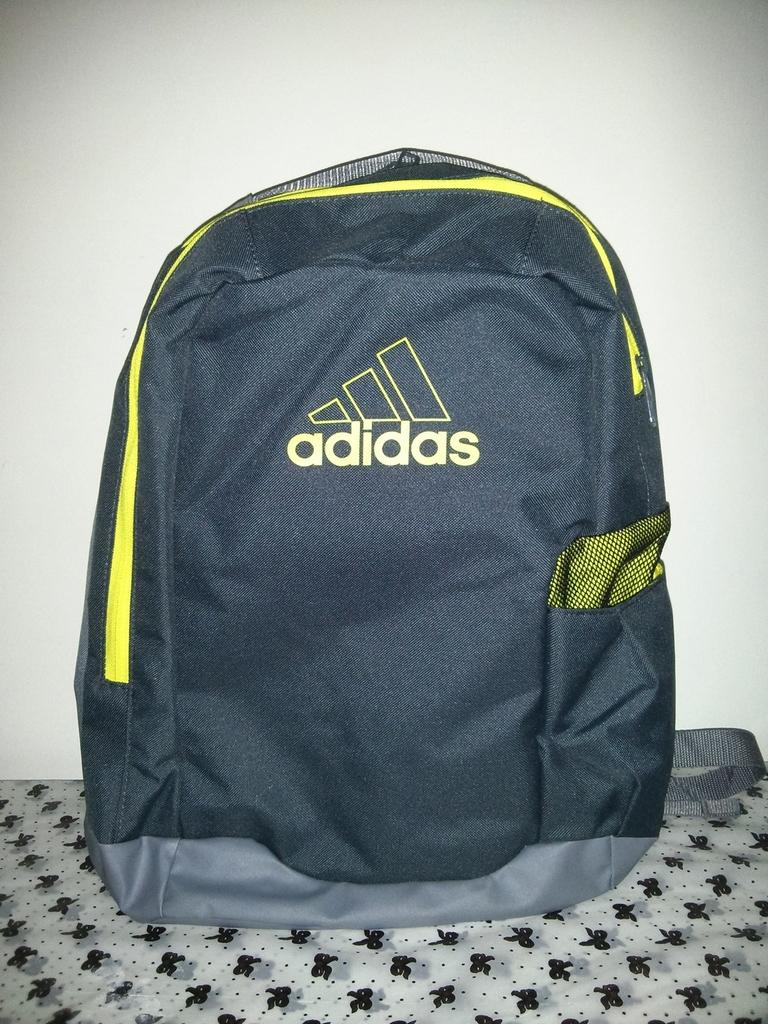What is the main piece of furniture in the foreground of the image? There is a couch in the foreground of the image. What is placed on the couch? There is an Adidas bag on the couch. What can be seen in the background of the image? The background of the image includes a wall. What color is the wall? The wall is painted white. What type of friction can be observed between the air and the ground in the image? There is no reference to air or ground in the image, so it is not possible to determine the type of friction between them. 